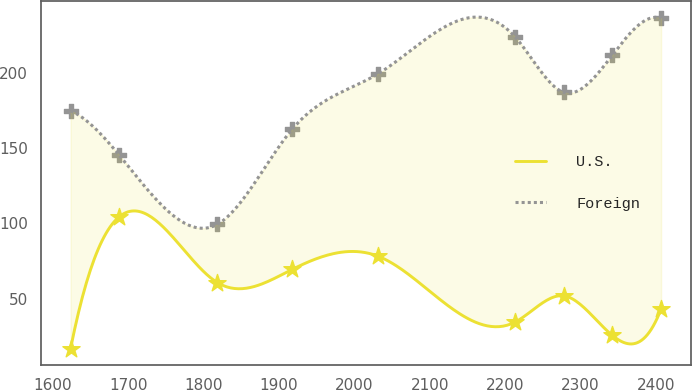<chart> <loc_0><loc_0><loc_500><loc_500><line_chart><ecel><fcel>U.S.<fcel>Foreign<nl><fcel>1623.62<fcel>16.65<fcel>175.09<nl><fcel>1688.28<fcel>104.53<fcel>145.45<nl><fcel>1818.45<fcel>60.6<fcel>99.46<nl><fcel>1917.57<fcel>69.39<fcel>162.75<nl><fcel>2031.57<fcel>78.18<fcel>199.77<nl><fcel>2212.93<fcel>34.23<fcel>224.45<nl><fcel>2277.59<fcel>51.81<fcel>187.43<nl><fcel>2342.25<fcel>25.44<fcel>212.11<nl><fcel>2406.91<fcel>43.02<fcel>236.79<nl></chart> 